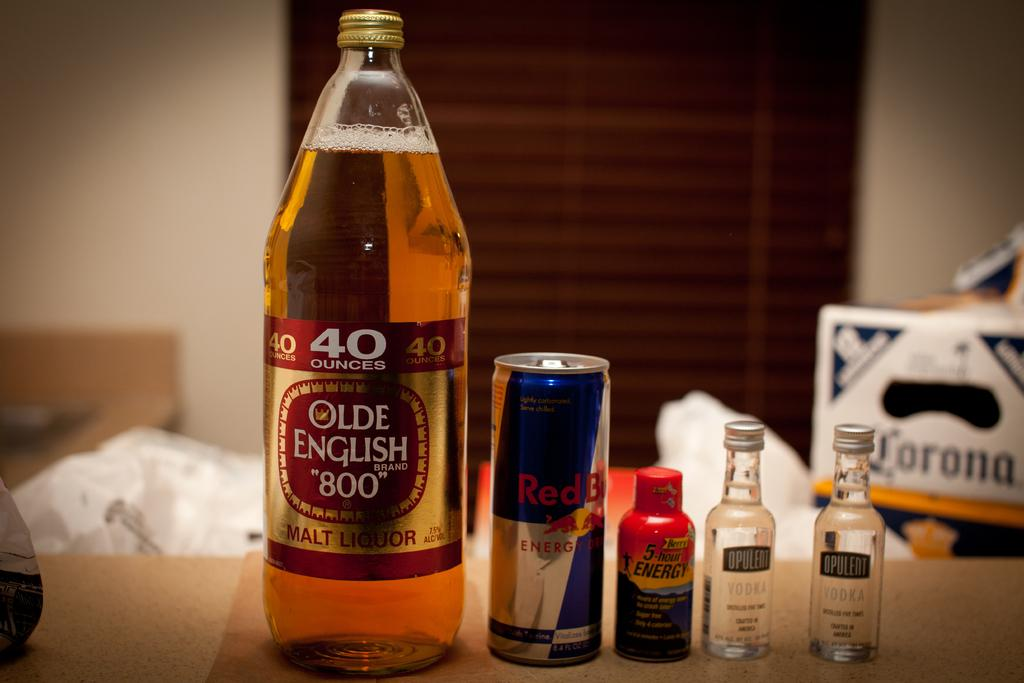<image>
Write a terse but informative summary of the picture. A 40 oz Olde English sits next to a Red Bull and other drinks on a table 